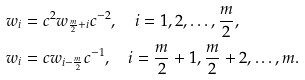Convert formula to latex. <formula><loc_0><loc_0><loc_500><loc_500>w _ { i } & = c ^ { 2 } w _ { \frac { m } { 2 } + i } c ^ { - 2 } , \quad i = 1 , 2 , \dots , \frac { m } 2 , \\ w _ { i } & = c w _ { i - \frac { m } 2 } c ^ { - 1 } , \quad i = \frac { m } 2 + 1 , \frac { m } 2 + 2 , \dots , m .</formula> 